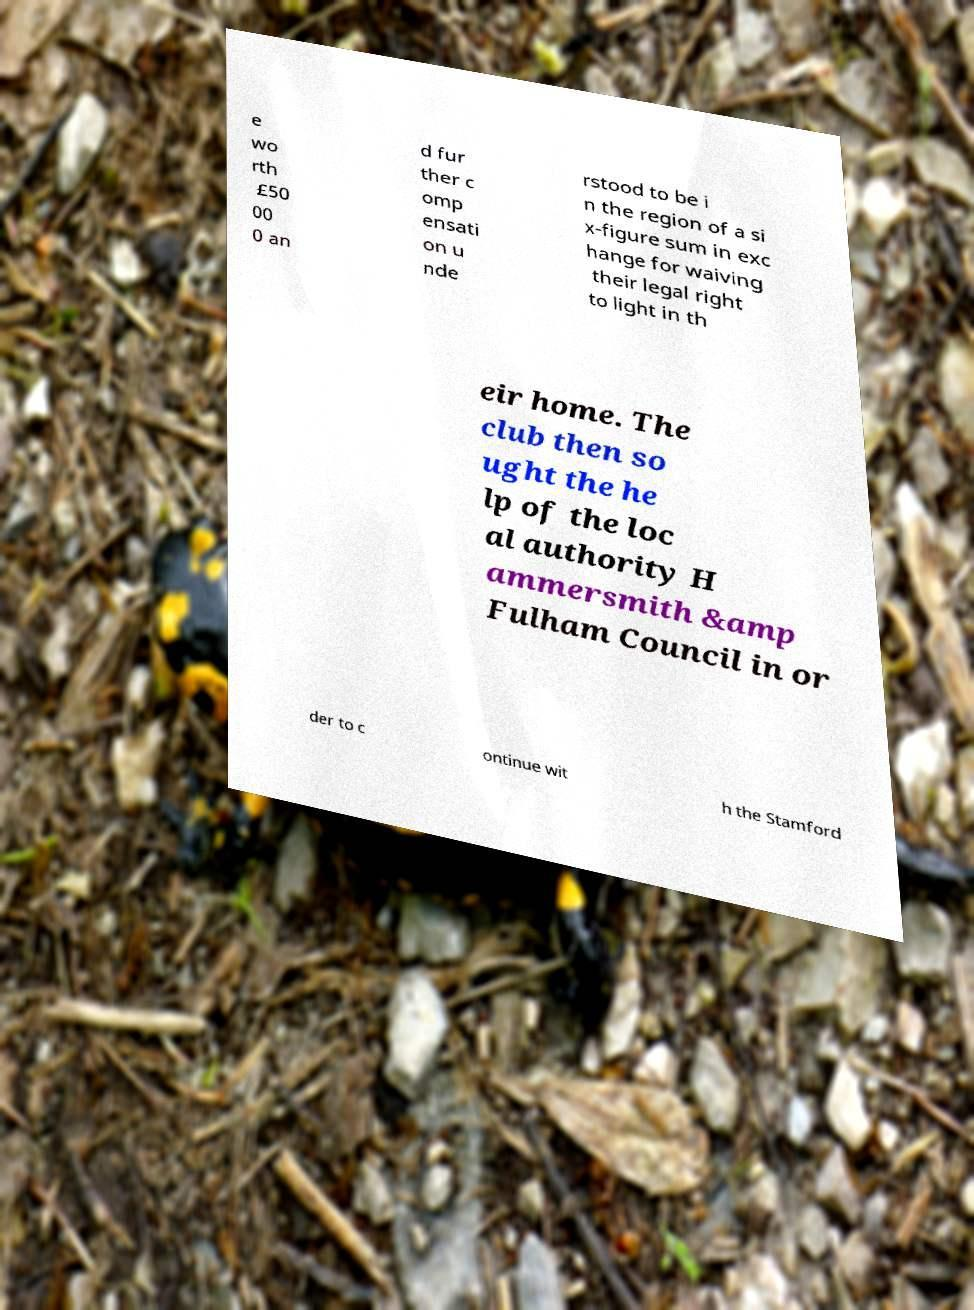There's text embedded in this image that I need extracted. Can you transcribe it verbatim? e wo rth £50 00 0 an d fur ther c omp ensati on u nde rstood to be i n the region of a si x-figure sum in exc hange for waiving their legal right to light in th eir home. The club then so ught the he lp of the loc al authority H ammersmith &amp Fulham Council in or der to c ontinue wit h the Stamford 